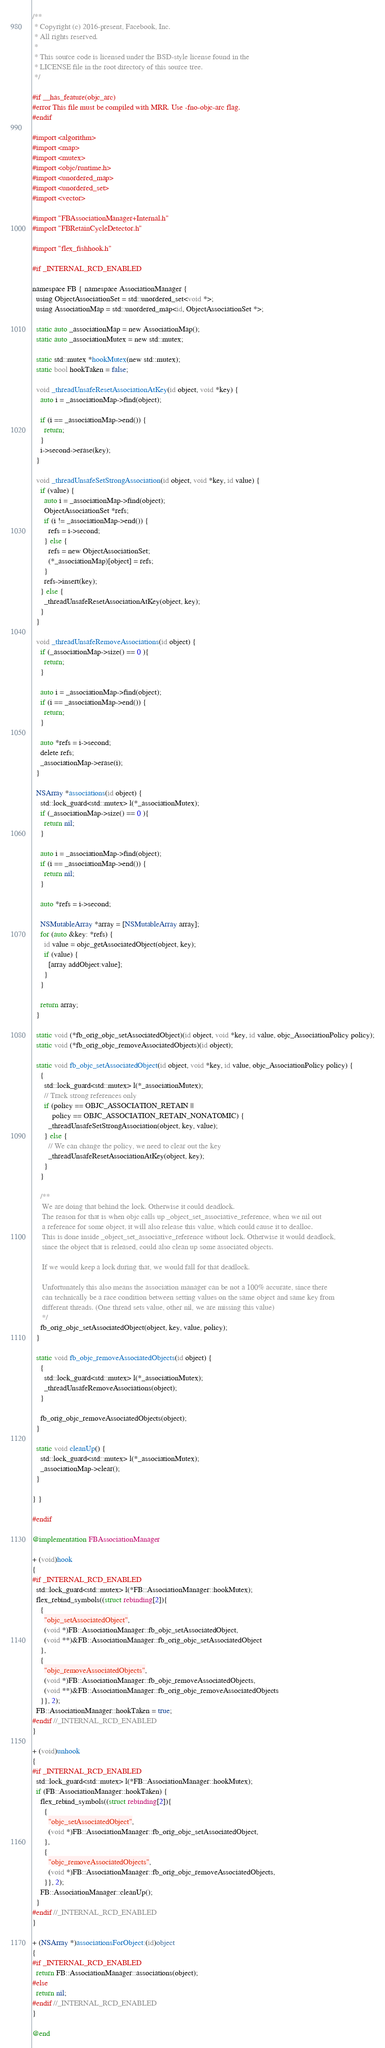<code> <loc_0><loc_0><loc_500><loc_500><_ObjectiveC_>/**
 * Copyright (c) 2016-present, Facebook, Inc.
 * All rights reserved.
 *
 * This source code is licensed under the BSD-style license found in the
 * LICENSE file in the root directory of this source tree.
 */

#if __has_feature(objc_arc)
#error This file must be compiled with MRR. Use -fno-objc-arc flag.
#endif

#import <algorithm>
#import <map>
#import <mutex>
#import <objc/runtime.h>
#import <unordered_map>
#import <unordered_set>
#import <vector>

#import "FBAssociationManager+Internal.h"
#import "FBRetainCycleDetector.h"

#import "flex_fishhook.h"

#if _INTERNAL_RCD_ENABLED

namespace FB { namespace AssociationManager {
  using ObjectAssociationSet = std::unordered_set<void *>;
  using AssociationMap = std::unordered_map<id, ObjectAssociationSet *>;

  static auto _associationMap = new AssociationMap();
  static auto _associationMutex = new std::mutex;

  static std::mutex *hookMutex(new std::mutex);
  static bool hookTaken = false;

  void _threadUnsafeResetAssociationAtKey(id object, void *key) {
    auto i = _associationMap->find(object);

    if (i == _associationMap->end()) {
      return;
    }
    i->second->erase(key);
  }

  void _threadUnsafeSetStrongAssociation(id object, void *key, id value) {
    if (value) {
      auto i = _associationMap->find(object);
      ObjectAssociationSet *refs;
      if (i != _associationMap->end()) {
        refs = i->second;
      } else {
        refs = new ObjectAssociationSet;
        (*_associationMap)[object] = refs;
      }
      refs->insert(key);
    } else {
      _threadUnsafeResetAssociationAtKey(object, key);
    }
  }

  void _threadUnsafeRemoveAssociations(id object) {
    if (_associationMap->size() == 0 ){
      return;
    }

    auto i = _associationMap->find(object);
    if (i == _associationMap->end()) {
      return;
    }

    auto *refs = i->second;
    delete refs;
    _associationMap->erase(i);
  }

  NSArray *associations(id object) {
    std::lock_guard<std::mutex> l(*_associationMutex);
    if (_associationMap->size() == 0 ){
      return nil;
    }

    auto i = _associationMap->find(object);
    if (i == _associationMap->end()) {
      return nil;
    }

    auto *refs = i->second;

    NSMutableArray *array = [NSMutableArray array];
    for (auto &key: *refs) {
      id value = objc_getAssociatedObject(object, key);
      if (value) {
        [array addObject:value];
      }
    }

    return array;
  }

  static void (*fb_orig_objc_setAssociatedObject)(id object, void *key, id value, objc_AssociationPolicy policy);
  static void (*fb_orig_objc_removeAssociatedObjects)(id object);

  static void fb_objc_setAssociatedObject(id object, void *key, id value, objc_AssociationPolicy policy) {
    {
      std::lock_guard<std::mutex> l(*_associationMutex);
      // Track strong references only
      if (policy == OBJC_ASSOCIATION_RETAIN ||
          policy == OBJC_ASSOCIATION_RETAIN_NONATOMIC) {
        _threadUnsafeSetStrongAssociation(object, key, value);
      } else {
        // We can change the policy, we need to clear out the key
        _threadUnsafeResetAssociationAtKey(object, key);
      }
    }

    /**
     We are doing that behind the lock. Otherwise it could deadlock.
     The reason for that is when objc calls up _object_set_associative_reference, when we nil out
     a reference for some object, it will also release this value, which could cause it to dealloc.
     This is done inside _object_set_associative_reference without lock. Otherwise it would deadlock,
     since the object that is released, could also clean up some associated objects.

     If we would keep a lock during that, we would fall for that deadlock.

     Unfortunately this also means the association manager can be not a 100% accurate, since there
     can technically be a race condition between setting values on the same object and same key from
     different threads. (One thread sets value, other nil, we are missing this value)
     */
    fb_orig_objc_setAssociatedObject(object, key, value, policy);
  }

  static void fb_objc_removeAssociatedObjects(id object) {
    {
      std::lock_guard<std::mutex> l(*_associationMutex);
      _threadUnsafeRemoveAssociations(object);
    }

    fb_orig_objc_removeAssociatedObjects(object);
  }

  static void cleanUp() {
    std::lock_guard<std::mutex> l(*_associationMutex);
    _associationMap->clear();
  }

} }

#endif

@implementation FBAssociationManager

+ (void)hook
{
#if _INTERNAL_RCD_ENABLED
  std::lock_guard<std::mutex> l(*FB::AssociationManager::hookMutex);
  flex_rebind_symbols((struct rebinding[2]){
    {
      "objc_setAssociatedObject",
      (void *)FB::AssociationManager::fb_objc_setAssociatedObject,
      (void **)&FB::AssociationManager::fb_orig_objc_setAssociatedObject
    },
    {
      "objc_removeAssociatedObjects",
      (void *)FB::AssociationManager::fb_objc_removeAssociatedObjects,
      (void **)&FB::AssociationManager::fb_orig_objc_removeAssociatedObjects
    }}, 2);
  FB::AssociationManager::hookTaken = true;
#endif //_INTERNAL_RCD_ENABLED
}

+ (void)unhook
{
#if _INTERNAL_RCD_ENABLED
  std::lock_guard<std::mutex> l(*FB::AssociationManager::hookMutex);
  if (FB::AssociationManager::hookTaken) {
    flex_rebind_symbols((struct rebinding[2]){
      {
        "objc_setAssociatedObject",
        (void *)FB::AssociationManager::fb_orig_objc_setAssociatedObject,
      },
      {
        "objc_removeAssociatedObjects",
        (void *)FB::AssociationManager::fb_orig_objc_removeAssociatedObjects,
      }}, 2);
    FB::AssociationManager::cleanUp();
  }
#endif //_INTERNAL_RCD_ENABLED
}

+ (NSArray *)associationsForObject:(id)object
{
#if _INTERNAL_RCD_ENABLED
  return FB::AssociationManager::associations(object);
#else
  return nil;
#endif //_INTERNAL_RCD_ENABLED
}

@end
</code> 